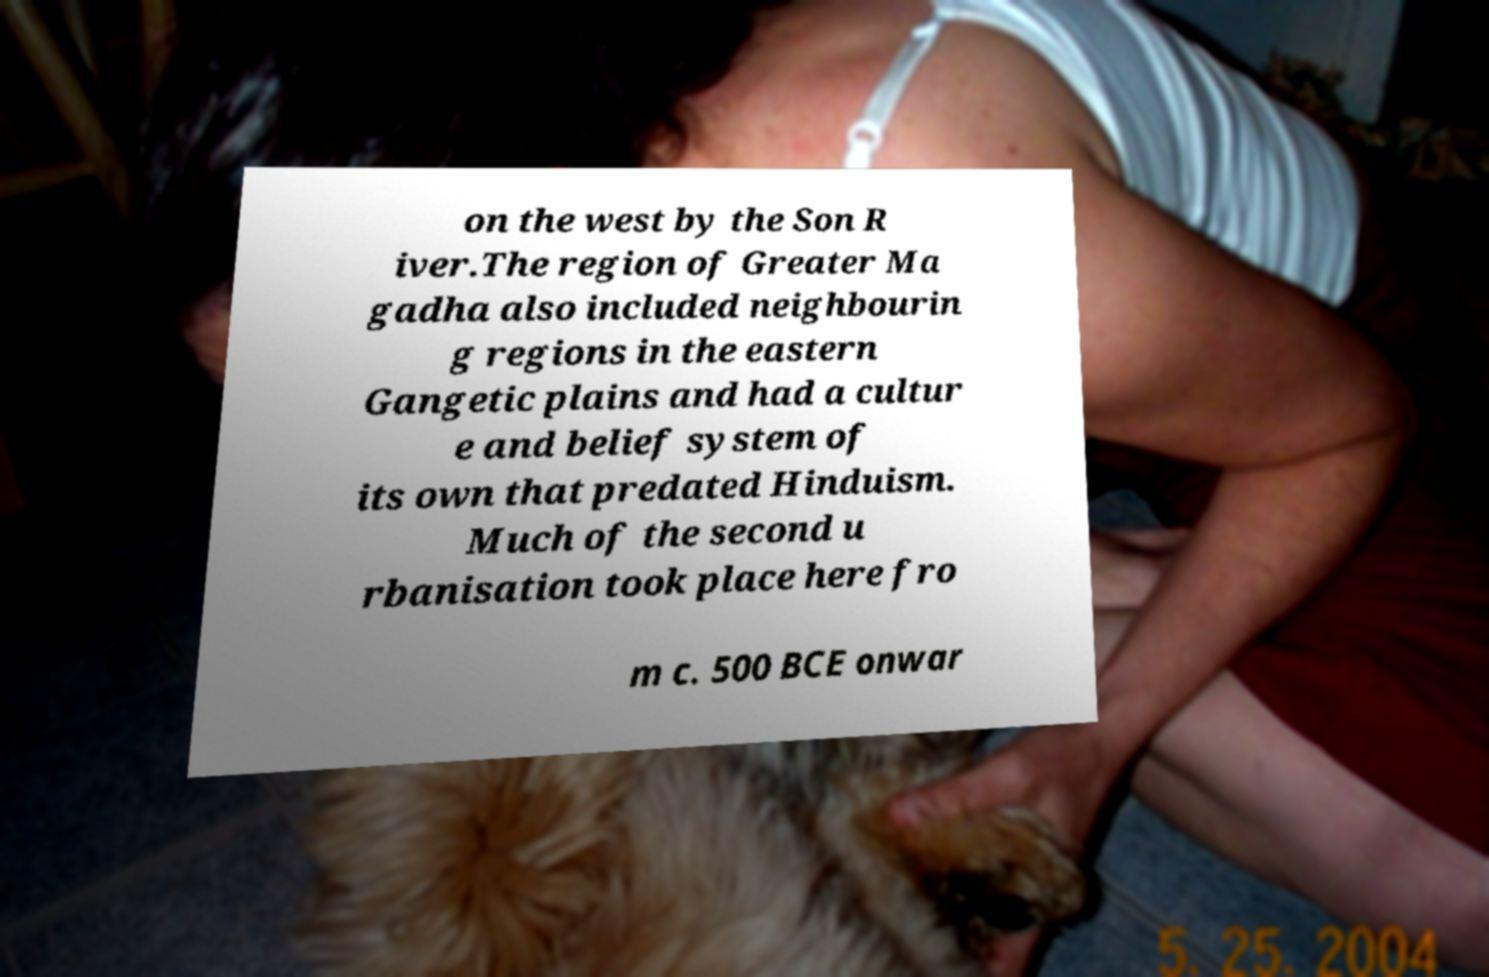Could you extract and type out the text from this image? on the west by the Son R iver.The region of Greater Ma gadha also included neighbourin g regions in the eastern Gangetic plains and had a cultur e and belief system of its own that predated Hinduism. Much of the second u rbanisation took place here fro m c. 500 BCE onwar 